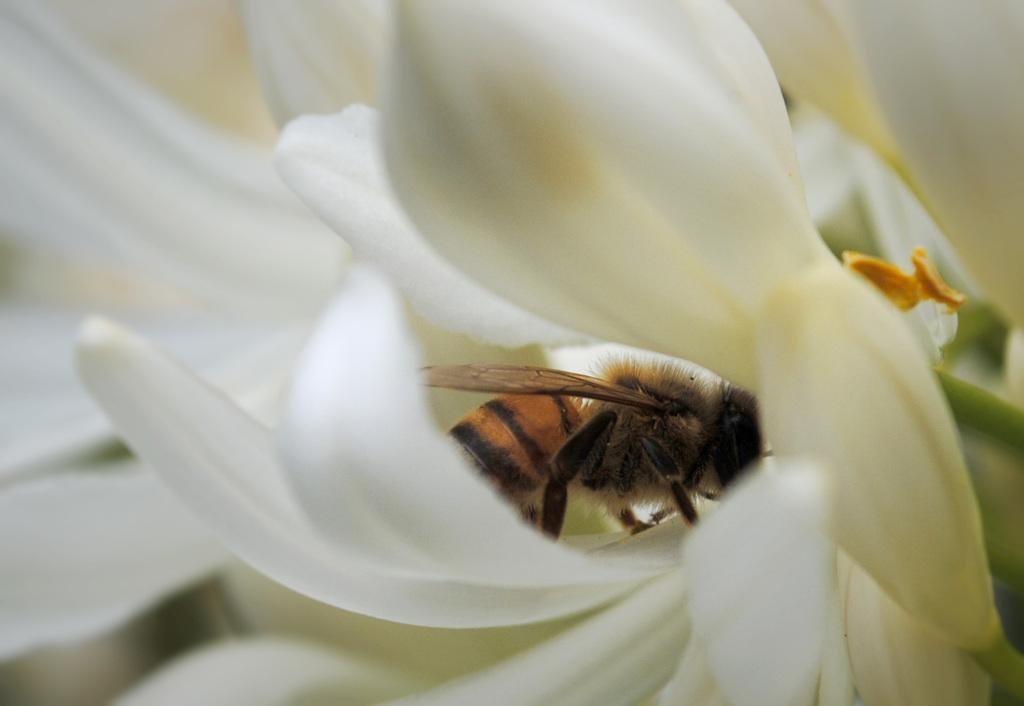What type of flower can be seen in the image? There is a white-colored flower in the image. What other living organism is present in the image? There is a brown-colored insect in the image. How would you describe the overall clarity of the image? The image is slightly blurry in the background. What type of locket is the insect wearing in the image? There is no locket present in the image, and the insect is not wearing any accessories. 